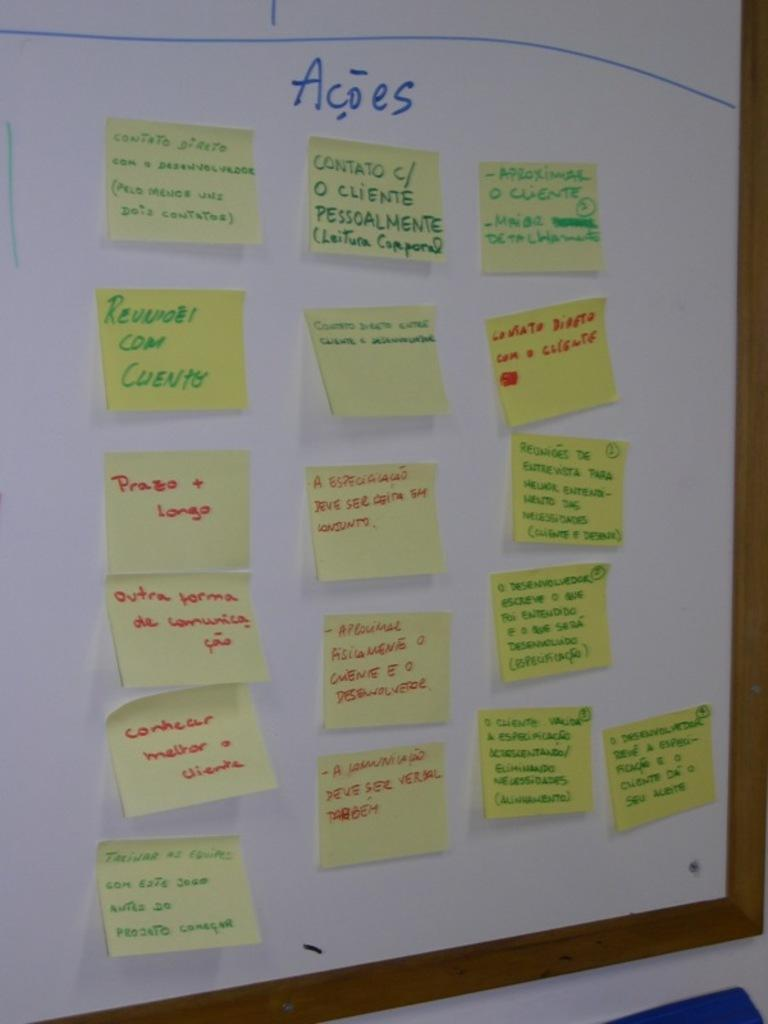What is the main object in the image? There is a white color board in the image. What is attached to the color board? Papers are attached to the board. What can be seen on the papers? There is writing on the papers. How many horses are running on the road in the image? There are no horses or roads present in the image; it features a white color board with papers attached. 